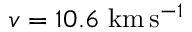<formula> <loc_0><loc_0><loc_500><loc_500>v = 1 0 . 6 k m \, s ^ { - 1 }</formula> 